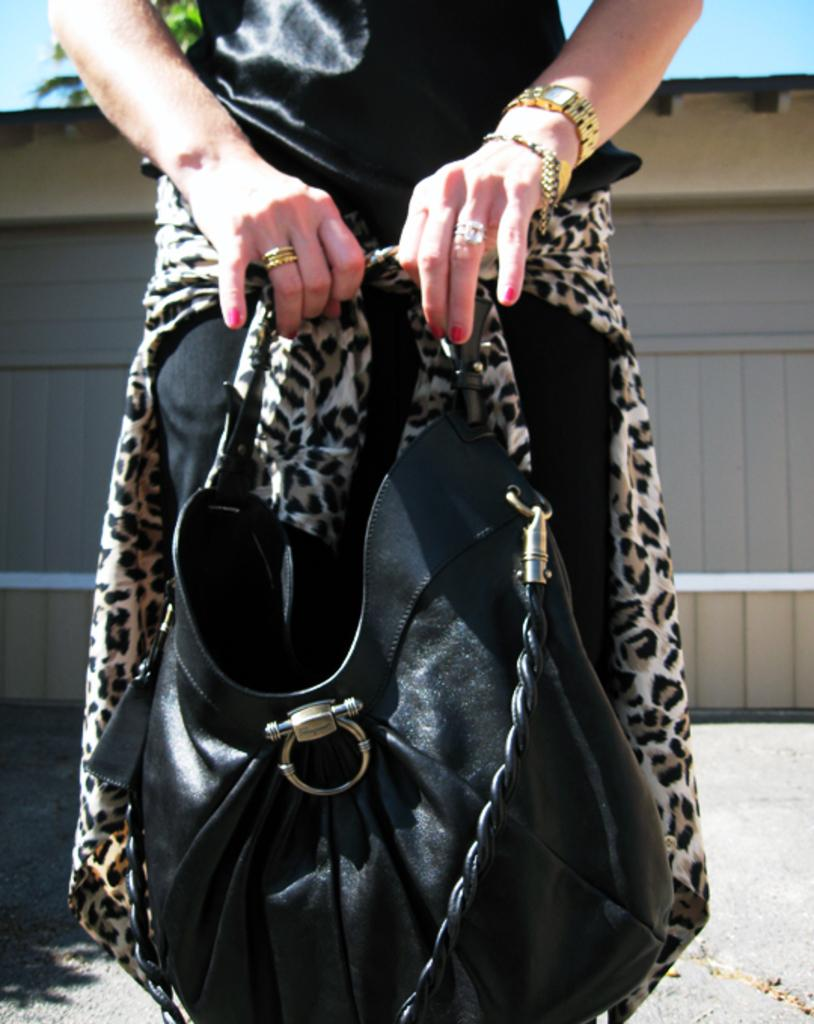Who is the main subject in the picture? There is a woman in the picture. What accessory is the woman wearing? The woman is wearing a gold watch. What object is the woman holding? The woman is holding a black handbag. What type of beam is being used by the woman in the image? There is no beam present in the image; the woman is simply wearing a gold watch and holding a black handbag. 